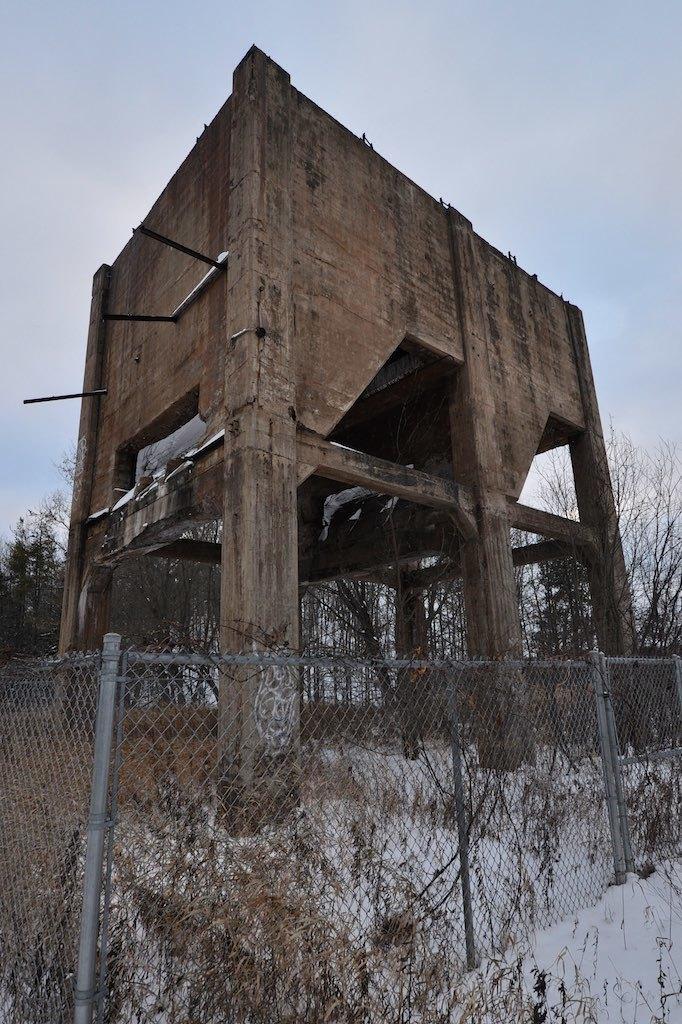Could you give a brief overview of what you see in this image? In this image in the front there is a fence and behind the fence there are trees and there is an object which is made up of wood and the sky is cloudy. 